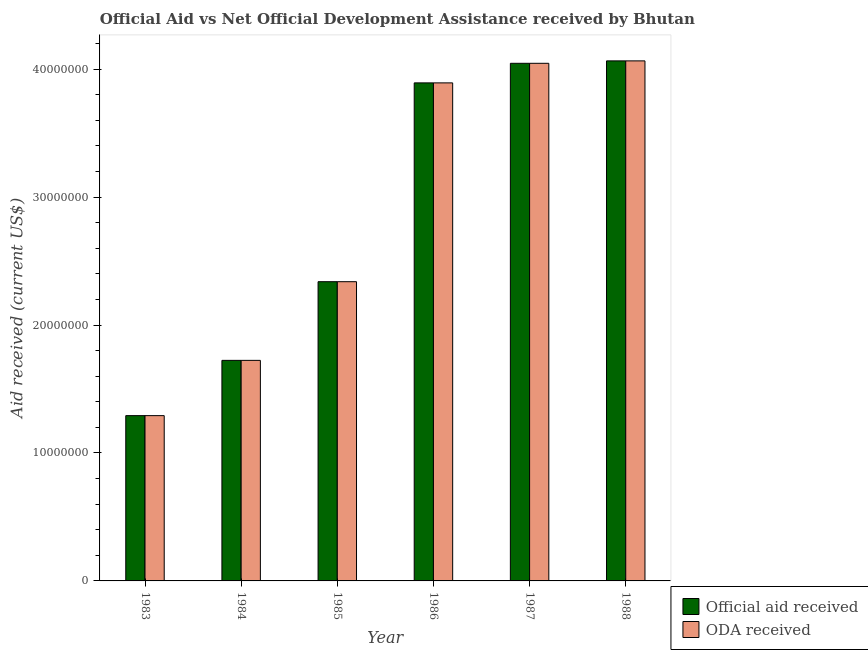How many different coloured bars are there?
Your answer should be very brief. 2. How many groups of bars are there?
Provide a succinct answer. 6. Are the number of bars per tick equal to the number of legend labels?
Your answer should be compact. Yes. Are the number of bars on each tick of the X-axis equal?
Your answer should be compact. Yes. How many bars are there on the 4th tick from the left?
Offer a very short reply. 2. What is the label of the 3rd group of bars from the left?
Offer a very short reply. 1985. What is the oda received in 1988?
Your answer should be very brief. 4.06e+07. Across all years, what is the maximum oda received?
Make the answer very short. 4.06e+07. Across all years, what is the minimum oda received?
Your answer should be compact. 1.29e+07. In which year was the oda received maximum?
Your answer should be compact. 1988. What is the total official aid received in the graph?
Your answer should be very brief. 1.74e+08. What is the difference between the oda received in 1983 and that in 1986?
Your answer should be compact. -2.60e+07. What is the difference between the oda received in 1986 and the official aid received in 1988?
Give a very brief answer. -1.72e+06. What is the average official aid received per year?
Keep it short and to the point. 2.89e+07. In how many years, is the official aid received greater than 2000000 US$?
Your answer should be very brief. 6. What is the ratio of the oda received in 1987 to that in 1988?
Your response must be concise. 1. Is the difference between the oda received in 1986 and 1987 greater than the difference between the official aid received in 1986 and 1987?
Provide a short and direct response. No. What is the difference between the highest and the second highest oda received?
Your response must be concise. 1.90e+05. What is the difference between the highest and the lowest oda received?
Provide a short and direct response. 2.77e+07. In how many years, is the official aid received greater than the average official aid received taken over all years?
Ensure brevity in your answer.  3. Is the sum of the oda received in 1983 and 1987 greater than the maximum official aid received across all years?
Your answer should be very brief. Yes. What does the 1st bar from the left in 1983 represents?
Offer a terse response. Official aid received. What does the 2nd bar from the right in 1984 represents?
Offer a terse response. Official aid received. How many years are there in the graph?
Your answer should be very brief. 6. What is the difference between two consecutive major ticks on the Y-axis?
Ensure brevity in your answer.  1.00e+07. Does the graph contain any zero values?
Provide a short and direct response. No. How many legend labels are there?
Your answer should be compact. 2. What is the title of the graph?
Make the answer very short. Official Aid vs Net Official Development Assistance received by Bhutan . Does "Researchers" appear as one of the legend labels in the graph?
Provide a succinct answer. No. What is the label or title of the X-axis?
Keep it short and to the point. Year. What is the label or title of the Y-axis?
Offer a terse response. Aid received (current US$). What is the Aid received (current US$) in Official aid received in 1983?
Your response must be concise. 1.29e+07. What is the Aid received (current US$) in ODA received in 1983?
Offer a very short reply. 1.29e+07. What is the Aid received (current US$) of Official aid received in 1984?
Your answer should be very brief. 1.72e+07. What is the Aid received (current US$) of ODA received in 1984?
Offer a very short reply. 1.72e+07. What is the Aid received (current US$) of Official aid received in 1985?
Your response must be concise. 2.34e+07. What is the Aid received (current US$) of ODA received in 1985?
Your response must be concise. 2.34e+07. What is the Aid received (current US$) in Official aid received in 1986?
Your response must be concise. 3.89e+07. What is the Aid received (current US$) of ODA received in 1986?
Provide a short and direct response. 3.89e+07. What is the Aid received (current US$) of Official aid received in 1987?
Your response must be concise. 4.05e+07. What is the Aid received (current US$) in ODA received in 1987?
Make the answer very short. 4.05e+07. What is the Aid received (current US$) in Official aid received in 1988?
Keep it short and to the point. 4.06e+07. What is the Aid received (current US$) in ODA received in 1988?
Offer a terse response. 4.06e+07. Across all years, what is the maximum Aid received (current US$) in Official aid received?
Your answer should be very brief. 4.06e+07. Across all years, what is the maximum Aid received (current US$) of ODA received?
Keep it short and to the point. 4.06e+07. Across all years, what is the minimum Aid received (current US$) of Official aid received?
Your answer should be very brief. 1.29e+07. Across all years, what is the minimum Aid received (current US$) in ODA received?
Your answer should be compact. 1.29e+07. What is the total Aid received (current US$) in Official aid received in the graph?
Provide a short and direct response. 1.74e+08. What is the total Aid received (current US$) of ODA received in the graph?
Your answer should be compact. 1.74e+08. What is the difference between the Aid received (current US$) in Official aid received in 1983 and that in 1984?
Your answer should be compact. -4.32e+06. What is the difference between the Aid received (current US$) of ODA received in 1983 and that in 1984?
Your response must be concise. -4.32e+06. What is the difference between the Aid received (current US$) of Official aid received in 1983 and that in 1985?
Keep it short and to the point. -1.05e+07. What is the difference between the Aid received (current US$) of ODA received in 1983 and that in 1985?
Make the answer very short. -1.05e+07. What is the difference between the Aid received (current US$) in Official aid received in 1983 and that in 1986?
Provide a short and direct response. -2.60e+07. What is the difference between the Aid received (current US$) in ODA received in 1983 and that in 1986?
Your answer should be compact. -2.60e+07. What is the difference between the Aid received (current US$) in Official aid received in 1983 and that in 1987?
Keep it short and to the point. -2.75e+07. What is the difference between the Aid received (current US$) of ODA received in 1983 and that in 1987?
Keep it short and to the point. -2.75e+07. What is the difference between the Aid received (current US$) of Official aid received in 1983 and that in 1988?
Offer a terse response. -2.77e+07. What is the difference between the Aid received (current US$) of ODA received in 1983 and that in 1988?
Make the answer very short. -2.77e+07. What is the difference between the Aid received (current US$) of Official aid received in 1984 and that in 1985?
Ensure brevity in your answer.  -6.15e+06. What is the difference between the Aid received (current US$) of ODA received in 1984 and that in 1985?
Offer a terse response. -6.15e+06. What is the difference between the Aid received (current US$) of Official aid received in 1984 and that in 1986?
Offer a terse response. -2.17e+07. What is the difference between the Aid received (current US$) in ODA received in 1984 and that in 1986?
Ensure brevity in your answer.  -2.17e+07. What is the difference between the Aid received (current US$) of Official aid received in 1984 and that in 1987?
Provide a short and direct response. -2.32e+07. What is the difference between the Aid received (current US$) in ODA received in 1984 and that in 1987?
Provide a succinct answer. -2.32e+07. What is the difference between the Aid received (current US$) of Official aid received in 1984 and that in 1988?
Offer a very short reply. -2.34e+07. What is the difference between the Aid received (current US$) of ODA received in 1984 and that in 1988?
Your answer should be very brief. -2.34e+07. What is the difference between the Aid received (current US$) in Official aid received in 1985 and that in 1986?
Ensure brevity in your answer.  -1.55e+07. What is the difference between the Aid received (current US$) of ODA received in 1985 and that in 1986?
Provide a succinct answer. -1.55e+07. What is the difference between the Aid received (current US$) of Official aid received in 1985 and that in 1987?
Offer a terse response. -1.71e+07. What is the difference between the Aid received (current US$) of ODA received in 1985 and that in 1987?
Offer a terse response. -1.71e+07. What is the difference between the Aid received (current US$) in Official aid received in 1985 and that in 1988?
Keep it short and to the point. -1.73e+07. What is the difference between the Aid received (current US$) of ODA received in 1985 and that in 1988?
Provide a succinct answer. -1.73e+07. What is the difference between the Aid received (current US$) of Official aid received in 1986 and that in 1987?
Your answer should be very brief. -1.53e+06. What is the difference between the Aid received (current US$) of ODA received in 1986 and that in 1987?
Offer a terse response. -1.53e+06. What is the difference between the Aid received (current US$) of Official aid received in 1986 and that in 1988?
Keep it short and to the point. -1.72e+06. What is the difference between the Aid received (current US$) of ODA received in 1986 and that in 1988?
Provide a succinct answer. -1.72e+06. What is the difference between the Aid received (current US$) in ODA received in 1987 and that in 1988?
Your answer should be very brief. -1.90e+05. What is the difference between the Aid received (current US$) in Official aid received in 1983 and the Aid received (current US$) in ODA received in 1984?
Give a very brief answer. -4.32e+06. What is the difference between the Aid received (current US$) in Official aid received in 1983 and the Aid received (current US$) in ODA received in 1985?
Offer a very short reply. -1.05e+07. What is the difference between the Aid received (current US$) of Official aid received in 1983 and the Aid received (current US$) of ODA received in 1986?
Give a very brief answer. -2.60e+07. What is the difference between the Aid received (current US$) of Official aid received in 1983 and the Aid received (current US$) of ODA received in 1987?
Ensure brevity in your answer.  -2.75e+07. What is the difference between the Aid received (current US$) in Official aid received in 1983 and the Aid received (current US$) in ODA received in 1988?
Provide a succinct answer. -2.77e+07. What is the difference between the Aid received (current US$) in Official aid received in 1984 and the Aid received (current US$) in ODA received in 1985?
Keep it short and to the point. -6.15e+06. What is the difference between the Aid received (current US$) of Official aid received in 1984 and the Aid received (current US$) of ODA received in 1986?
Your response must be concise. -2.17e+07. What is the difference between the Aid received (current US$) of Official aid received in 1984 and the Aid received (current US$) of ODA received in 1987?
Offer a terse response. -2.32e+07. What is the difference between the Aid received (current US$) of Official aid received in 1984 and the Aid received (current US$) of ODA received in 1988?
Give a very brief answer. -2.34e+07. What is the difference between the Aid received (current US$) in Official aid received in 1985 and the Aid received (current US$) in ODA received in 1986?
Make the answer very short. -1.55e+07. What is the difference between the Aid received (current US$) in Official aid received in 1985 and the Aid received (current US$) in ODA received in 1987?
Give a very brief answer. -1.71e+07. What is the difference between the Aid received (current US$) of Official aid received in 1985 and the Aid received (current US$) of ODA received in 1988?
Ensure brevity in your answer.  -1.73e+07. What is the difference between the Aid received (current US$) in Official aid received in 1986 and the Aid received (current US$) in ODA received in 1987?
Offer a very short reply. -1.53e+06. What is the difference between the Aid received (current US$) of Official aid received in 1986 and the Aid received (current US$) of ODA received in 1988?
Provide a short and direct response. -1.72e+06. What is the average Aid received (current US$) of Official aid received per year?
Make the answer very short. 2.89e+07. What is the average Aid received (current US$) in ODA received per year?
Make the answer very short. 2.89e+07. In the year 1983, what is the difference between the Aid received (current US$) in Official aid received and Aid received (current US$) in ODA received?
Make the answer very short. 0. In the year 1986, what is the difference between the Aid received (current US$) of Official aid received and Aid received (current US$) of ODA received?
Ensure brevity in your answer.  0. In the year 1987, what is the difference between the Aid received (current US$) of Official aid received and Aid received (current US$) of ODA received?
Offer a terse response. 0. In the year 1988, what is the difference between the Aid received (current US$) of Official aid received and Aid received (current US$) of ODA received?
Offer a terse response. 0. What is the ratio of the Aid received (current US$) in Official aid received in 1983 to that in 1984?
Offer a terse response. 0.75. What is the ratio of the Aid received (current US$) of ODA received in 1983 to that in 1984?
Offer a very short reply. 0.75. What is the ratio of the Aid received (current US$) in Official aid received in 1983 to that in 1985?
Offer a terse response. 0.55. What is the ratio of the Aid received (current US$) of ODA received in 1983 to that in 1985?
Ensure brevity in your answer.  0.55. What is the ratio of the Aid received (current US$) in Official aid received in 1983 to that in 1986?
Keep it short and to the point. 0.33. What is the ratio of the Aid received (current US$) in ODA received in 1983 to that in 1986?
Provide a succinct answer. 0.33. What is the ratio of the Aid received (current US$) of Official aid received in 1983 to that in 1987?
Provide a short and direct response. 0.32. What is the ratio of the Aid received (current US$) in ODA received in 1983 to that in 1987?
Keep it short and to the point. 0.32. What is the ratio of the Aid received (current US$) of Official aid received in 1983 to that in 1988?
Offer a terse response. 0.32. What is the ratio of the Aid received (current US$) of ODA received in 1983 to that in 1988?
Give a very brief answer. 0.32. What is the ratio of the Aid received (current US$) of Official aid received in 1984 to that in 1985?
Give a very brief answer. 0.74. What is the ratio of the Aid received (current US$) of ODA received in 1984 to that in 1985?
Give a very brief answer. 0.74. What is the ratio of the Aid received (current US$) of Official aid received in 1984 to that in 1986?
Your answer should be compact. 0.44. What is the ratio of the Aid received (current US$) in ODA received in 1984 to that in 1986?
Your response must be concise. 0.44. What is the ratio of the Aid received (current US$) of Official aid received in 1984 to that in 1987?
Ensure brevity in your answer.  0.43. What is the ratio of the Aid received (current US$) in ODA received in 1984 to that in 1987?
Make the answer very short. 0.43. What is the ratio of the Aid received (current US$) of Official aid received in 1984 to that in 1988?
Make the answer very short. 0.42. What is the ratio of the Aid received (current US$) in ODA received in 1984 to that in 1988?
Provide a short and direct response. 0.42. What is the ratio of the Aid received (current US$) of Official aid received in 1985 to that in 1986?
Offer a very short reply. 0.6. What is the ratio of the Aid received (current US$) in ODA received in 1985 to that in 1986?
Your answer should be very brief. 0.6. What is the ratio of the Aid received (current US$) of Official aid received in 1985 to that in 1987?
Your answer should be very brief. 0.58. What is the ratio of the Aid received (current US$) in ODA received in 1985 to that in 1987?
Provide a short and direct response. 0.58. What is the ratio of the Aid received (current US$) of Official aid received in 1985 to that in 1988?
Your answer should be very brief. 0.58. What is the ratio of the Aid received (current US$) in ODA received in 1985 to that in 1988?
Your answer should be compact. 0.58. What is the ratio of the Aid received (current US$) of Official aid received in 1986 to that in 1987?
Provide a short and direct response. 0.96. What is the ratio of the Aid received (current US$) of ODA received in 1986 to that in 1987?
Offer a terse response. 0.96. What is the ratio of the Aid received (current US$) of Official aid received in 1986 to that in 1988?
Offer a very short reply. 0.96. What is the ratio of the Aid received (current US$) in ODA received in 1986 to that in 1988?
Make the answer very short. 0.96. What is the difference between the highest and the lowest Aid received (current US$) in Official aid received?
Offer a very short reply. 2.77e+07. What is the difference between the highest and the lowest Aid received (current US$) in ODA received?
Offer a terse response. 2.77e+07. 